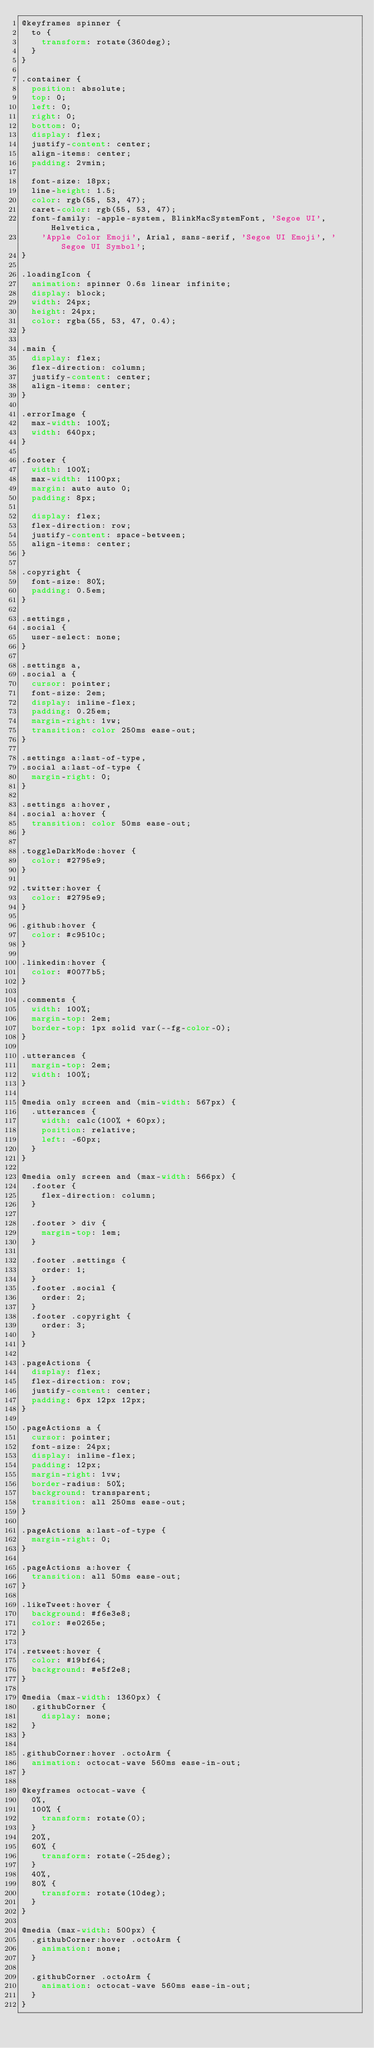<code> <loc_0><loc_0><loc_500><loc_500><_CSS_>@keyframes spinner {
  to {
    transform: rotate(360deg);
  }
}

.container {
  position: absolute;
  top: 0;
  left: 0;
  right: 0;
  bottom: 0;
  display: flex;
  justify-content: center;
  align-items: center;
  padding: 2vmin;

  font-size: 18px;
  line-height: 1.5;
  color: rgb(55, 53, 47);
  caret-color: rgb(55, 53, 47);
  font-family: -apple-system, BlinkMacSystemFont, 'Segoe UI', Helvetica,
    'Apple Color Emoji', Arial, sans-serif, 'Segoe UI Emoji', 'Segoe UI Symbol';
}

.loadingIcon {
  animation: spinner 0.6s linear infinite;
  display: block;
  width: 24px;
  height: 24px;
  color: rgba(55, 53, 47, 0.4);
}

.main {
  display: flex;
  flex-direction: column;
  justify-content: center;
  align-items: center;
}

.errorImage {
  max-width: 100%;
  width: 640px;
}

.footer {
  width: 100%;
  max-width: 1100px;
  margin: auto auto 0;
  padding: 8px;

  display: flex;
  flex-direction: row;
  justify-content: space-between;
  align-items: center;
}

.copyright {
  font-size: 80%;
  padding: 0.5em;
}

.settings,
.social {
  user-select: none;
}

.settings a,
.social a {
  cursor: pointer;
  font-size: 2em;
  display: inline-flex;
  padding: 0.25em;
  margin-right: 1vw;
  transition: color 250ms ease-out;
}

.settings a:last-of-type,
.social a:last-of-type {
  margin-right: 0;
}

.settings a:hover,
.social a:hover {
  transition: color 50ms ease-out;
}

.toggleDarkMode:hover {
  color: #2795e9;
}

.twitter:hover {
  color: #2795e9;
}

.github:hover {
  color: #c9510c;
}

.linkedin:hover {
  color: #0077b5;
}

.comments {
  width: 100%;
  margin-top: 2em;
  border-top: 1px solid var(--fg-color-0);
}

.utterances {
  margin-top: 2em;
  width: 100%;
}

@media only screen and (min-width: 567px) {
  .utterances {
    width: calc(100% + 60px);
    position: relative;
    left: -60px;
  }
}

@media only screen and (max-width: 566px) {
  .footer {
    flex-direction: column;
  }

  .footer > div {
    margin-top: 1em;
  }

  .footer .settings {
    order: 1;
  }
  .footer .social {
    order: 2;
  }
  .footer .copyright {
    order: 3;
  }
}

.pageActions {
  display: flex;
  flex-direction: row;
  justify-content: center;
  padding: 6px 12px 12px;
}

.pageActions a {
  cursor: pointer;
  font-size: 24px;
  display: inline-flex;
  padding: 12px;
  margin-right: 1vw;
  border-radius: 50%;
  background: transparent;
  transition: all 250ms ease-out;
}

.pageActions a:last-of-type {
  margin-right: 0;
}

.pageActions a:hover {
  transition: all 50ms ease-out;
}

.likeTweet:hover {
  background: #f6e3e8;
  color: #e0265e;
}

.retweet:hover {
  color: #19bf64;
  background: #e5f2e8;
}

@media (max-width: 1360px) {
  .githubCorner {
    display: none;
  }
}

.githubCorner:hover .octoArm {
  animation: octocat-wave 560ms ease-in-out;
}

@keyframes octocat-wave {
  0%,
  100% {
    transform: rotate(0);
  }
  20%,
  60% {
    transform: rotate(-25deg);
  }
  40%,
  80% {
    transform: rotate(10deg);
  }
}

@media (max-width: 500px) {
  .githubCorner:hover .octoArm {
    animation: none;
  }

  .githubCorner .octoArm {
    animation: octocat-wave 560ms ease-in-out;
  }
}
</code> 